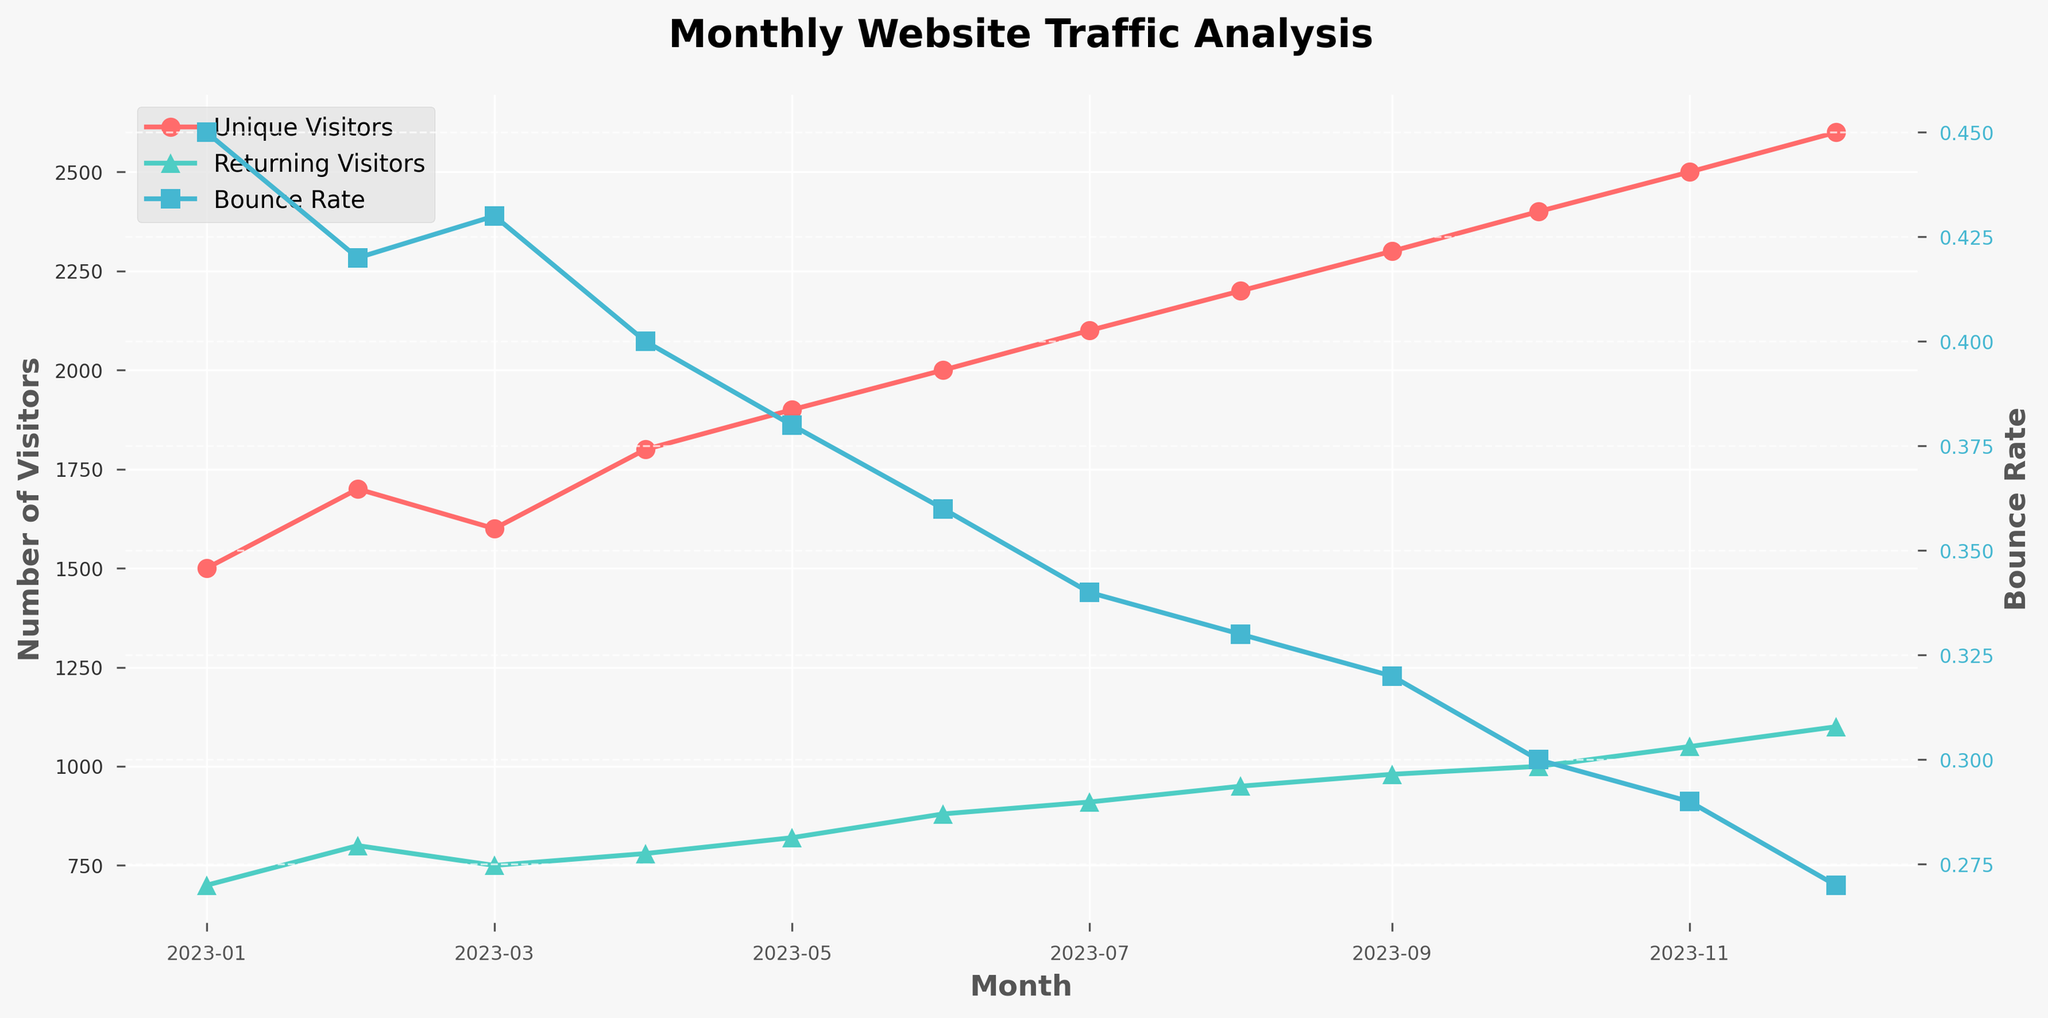What is the title of the figure? The title of the figure is located at the top center of the plot and usually describes what the chart represents.
Answer: Monthly Website Traffic Analysis How many unique visitors were there in March 2023? By examining the plot, locate the data point corresponding to March 2023 under the "Unique Visitors" line, represented by red circles.
Answer: 1600 Which month had the highest bounce rate? The bounce rate is depicted by the "Bounce Rate" line in blue squares. The highest data point along this line indicates the month with the highest bounce rate.
Answer: January 2023 What are the values of unique visitors and returning visitors in November 2023? To find these values, look at the data points for November 2023 across both the "Unique Visitors" (red circles) and "Returning Visitors" (green triangles) lines.
Answer: 2500 unique visitors and 1050 returning visitors How did the bounce rate change from January to December 2023? Compare the y-values of the bounce rate line (blue squares) for January and December. The bounce rate starts at 0.45 in January and falls to 0.27 by December.
Answer: It decreased from 0.45 to 0.27 In which month do returning visitors first exceed 900, and how many unique visitors were there in that month? Locate the first month where the "Returning Visitors" (green triangles) crosses the 900 mark. For that month, check the corresponding "Unique Visitors" value (red circles).
Answer: July 2023 with 2100 unique visitors Which month had the lowest bounce rate and what was its value? Identify the lowest data point on the bounce rate line (blue squares) and determine the corresponding month and y-value.
Answer: December 2023 with a bounce rate of 0.27 How much did the number of unique visitors increase from June to October 2023? Calculate the difference in the "Unique Visitors" line (red circles) between June and October. Subtract the June value from the October value.
Answer: Increased by 400 Did the bounce rate consistently decrease every month? Check the bounce rate (blue squares) for each month sequentially to see if it continually decreases without any increase in between.
Answer: Yes How many months had unique visitors less than 2000? Count the months where the "Unique Visitors" value (red circles) is below the 2000 mark by inspecting the plot.
Answer: 5 months 